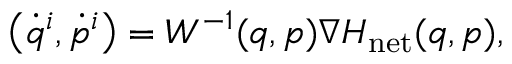<formula> <loc_0><loc_0><loc_500><loc_500>\begin{array} { r } { \left ( \dot { q } ^ { i } , \dot { p } ^ { i } \right ) = W ^ { - 1 } ( q , p ) \nabla H _ { n e t } ( q , p ) , } \end{array}</formula> 